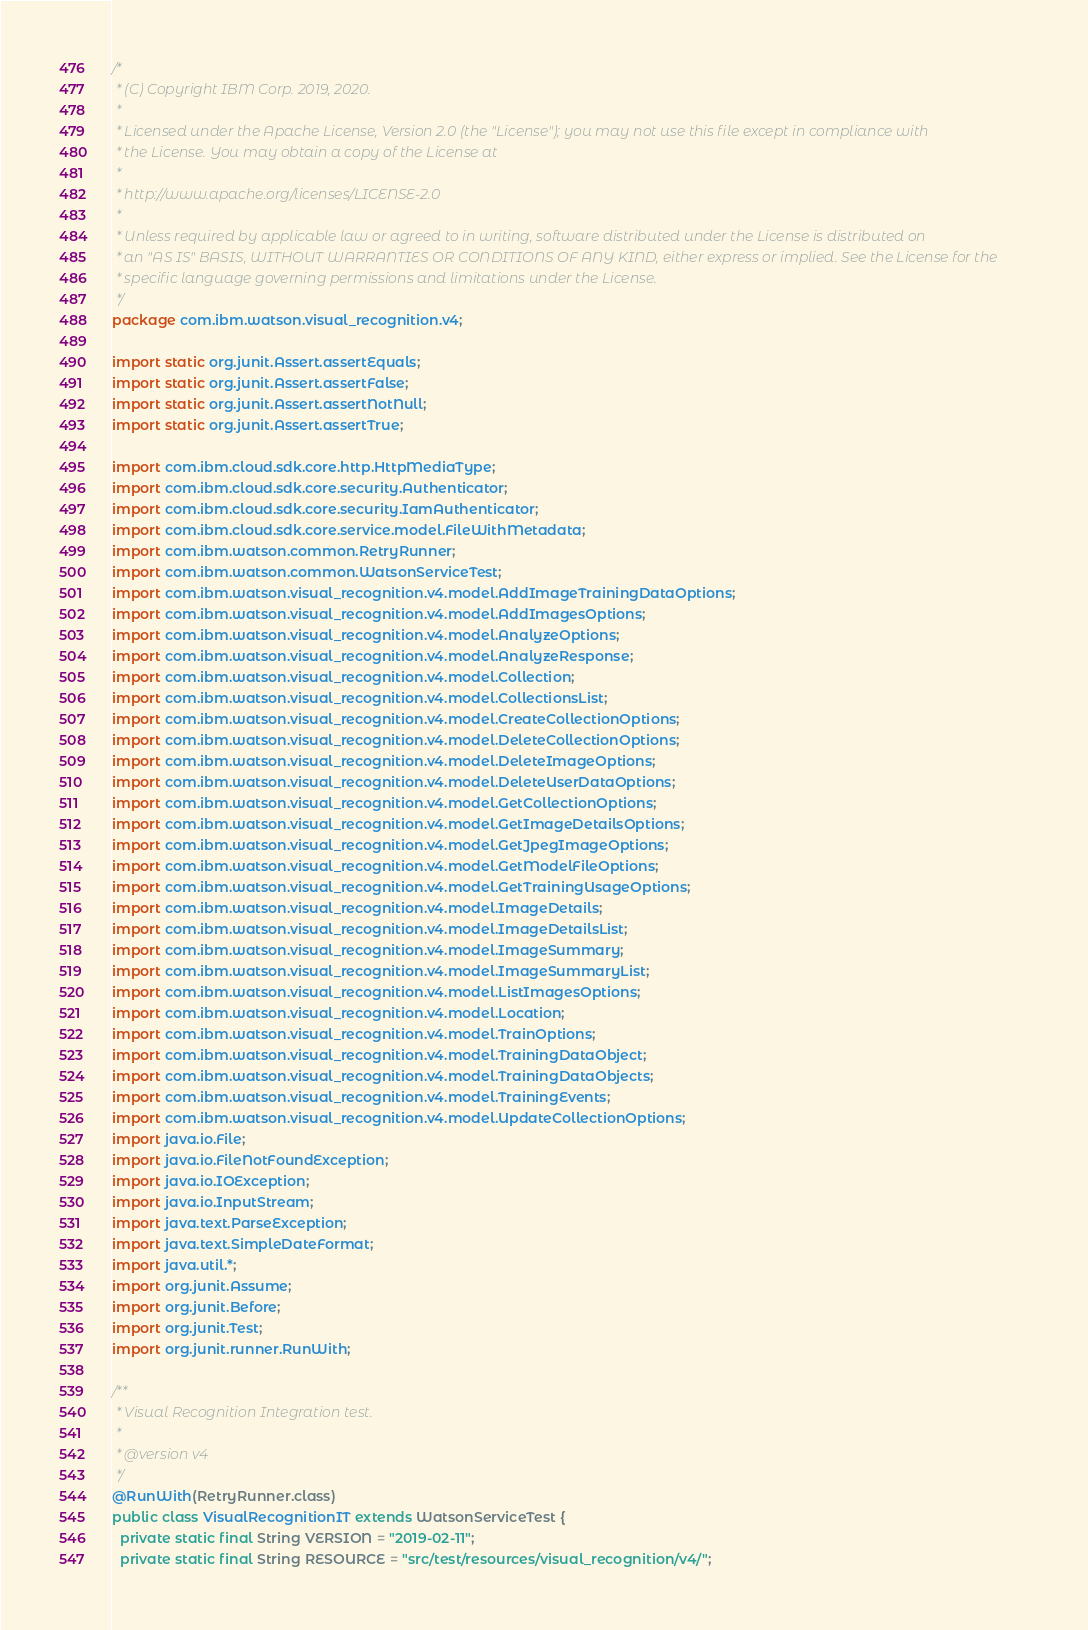<code> <loc_0><loc_0><loc_500><loc_500><_Java_>/*
 * (C) Copyright IBM Corp. 2019, 2020.
 *
 * Licensed under the Apache License, Version 2.0 (the "License"); you may not use this file except in compliance with
 * the License. You may obtain a copy of the License at
 *
 * http://www.apache.org/licenses/LICENSE-2.0
 *
 * Unless required by applicable law or agreed to in writing, software distributed under the License is distributed on
 * an "AS IS" BASIS, WITHOUT WARRANTIES OR CONDITIONS OF ANY KIND, either express or implied. See the License for the
 * specific language governing permissions and limitations under the License.
 */
package com.ibm.watson.visual_recognition.v4;

import static org.junit.Assert.assertEquals;
import static org.junit.Assert.assertFalse;
import static org.junit.Assert.assertNotNull;
import static org.junit.Assert.assertTrue;

import com.ibm.cloud.sdk.core.http.HttpMediaType;
import com.ibm.cloud.sdk.core.security.Authenticator;
import com.ibm.cloud.sdk.core.security.IamAuthenticator;
import com.ibm.cloud.sdk.core.service.model.FileWithMetadata;
import com.ibm.watson.common.RetryRunner;
import com.ibm.watson.common.WatsonServiceTest;
import com.ibm.watson.visual_recognition.v4.model.AddImageTrainingDataOptions;
import com.ibm.watson.visual_recognition.v4.model.AddImagesOptions;
import com.ibm.watson.visual_recognition.v4.model.AnalyzeOptions;
import com.ibm.watson.visual_recognition.v4.model.AnalyzeResponse;
import com.ibm.watson.visual_recognition.v4.model.Collection;
import com.ibm.watson.visual_recognition.v4.model.CollectionsList;
import com.ibm.watson.visual_recognition.v4.model.CreateCollectionOptions;
import com.ibm.watson.visual_recognition.v4.model.DeleteCollectionOptions;
import com.ibm.watson.visual_recognition.v4.model.DeleteImageOptions;
import com.ibm.watson.visual_recognition.v4.model.DeleteUserDataOptions;
import com.ibm.watson.visual_recognition.v4.model.GetCollectionOptions;
import com.ibm.watson.visual_recognition.v4.model.GetImageDetailsOptions;
import com.ibm.watson.visual_recognition.v4.model.GetJpegImageOptions;
import com.ibm.watson.visual_recognition.v4.model.GetModelFileOptions;
import com.ibm.watson.visual_recognition.v4.model.GetTrainingUsageOptions;
import com.ibm.watson.visual_recognition.v4.model.ImageDetails;
import com.ibm.watson.visual_recognition.v4.model.ImageDetailsList;
import com.ibm.watson.visual_recognition.v4.model.ImageSummary;
import com.ibm.watson.visual_recognition.v4.model.ImageSummaryList;
import com.ibm.watson.visual_recognition.v4.model.ListImagesOptions;
import com.ibm.watson.visual_recognition.v4.model.Location;
import com.ibm.watson.visual_recognition.v4.model.TrainOptions;
import com.ibm.watson.visual_recognition.v4.model.TrainingDataObject;
import com.ibm.watson.visual_recognition.v4.model.TrainingDataObjects;
import com.ibm.watson.visual_recognition.v4.model.TrainingEvents;
import com.ibm.watson.visual_recognition.v4.model.UpdateCollectionOptions;
import java.io.File;
import java.io.FileNotFoundException;
import java.io.IOException;
import java.io.InputStream;
import java.text.ParseException;
import java.text.SimpleDateFormat;
import java.util.*;
import org.junit.Assume;
import org.junit.Before;
import org.junit.Test;
import org.junit.runner.RunWith;

/**
 * Visual Recognition Integration test.
 *
 * @version v4
 */
@RunWith(RetryRunner.class)
public class VisualRecognitionIT extends WatsonServiceTest {
  private static final String VERSION = "2019-02-11";
  private static final String RESOURCE = "src/test/resources/visual_recognition/v4/";</code> 